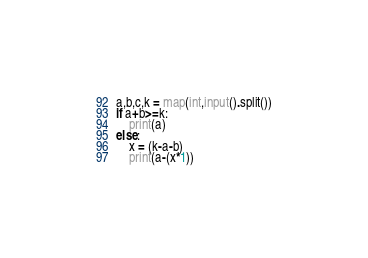<code> <loc_0><loc_0><loc_500><loc_500><_Python_>a,b,c,k = map(int,input().split())
if a+b>=k:
    print(a)
else:
    x = (k-a-b)
    print(a-(x*1))</code> 